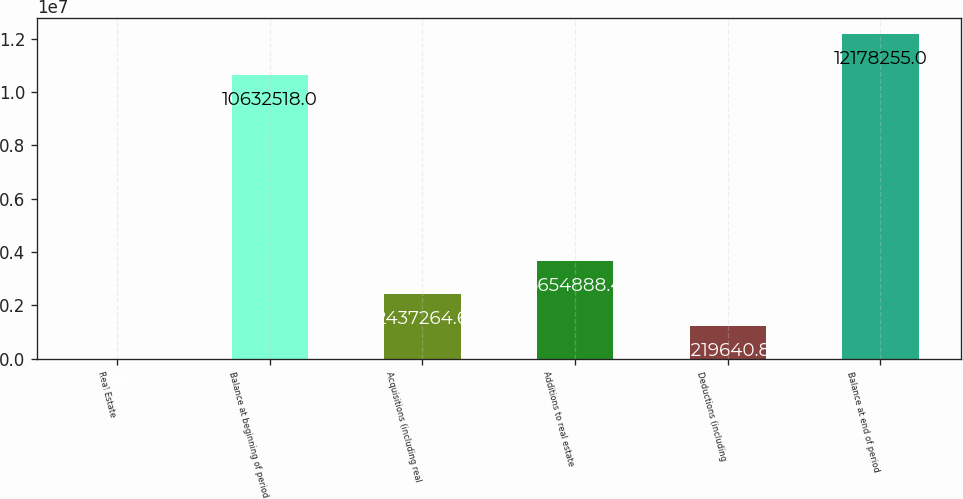Convert chart to OTSL. <chart><loc_0><loc_0><loc_500><loc_500><bar_chart><fcel>Real Estate<fcel>Balance at beginning of period<fcel>Acquisitions (including real<fcel>Additions to real estate<fcel>Deductions (including<fcel>Balance at end of period<nl><fcel>2017<fcel>1.06325e+07<fcel>2.43726e+06<fcel>3.65489e+06<fcel>1.21964e+06<fcel>1.21783e+07<nl></chart> 